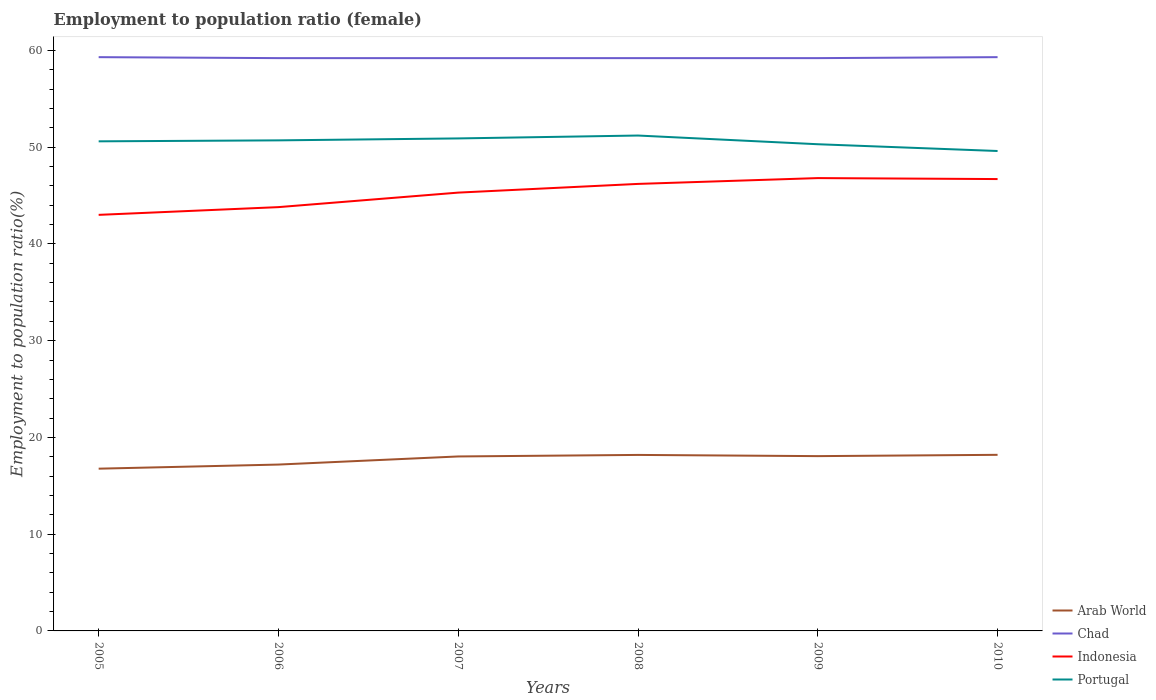Is the number of lines equal to the number of legend labels?
Ensure brevity in your answer.  Yes. Across all years, what is the maximum employment to population ratio in Portugal?
Your response must be concise. 49.6. In which year was the employment to population ratio in Portugal maximum?
Your response must be concise. 2010. What is the difference between the highest and the second highest employment to population ratio in Arab World?
Make the answer very short. 1.43. Is the employment to population ratio in Portugal strictly greater than the employment to population ratio in Chad over the years?
Your answer should be very brief. Yes. How many lines are there?
Your answer should be very brief. 4. What is the difference between two consecutive major ticks on the Y-axis?
Offer a terse response. 10. How are the legend labels stacked?
Offer a very short reply. Vertical. What is the title of the graph?
Your answer should be very brief. Employment to population ratio (female). Does "OECD members" appear as one of the legend labels in the graph?
Your answer should be compact. No. What is the Employment to population ratio(%) in Arab World in 2005?
Give a very brief answer. 16.77. What is the Employment to population ratio(%) in Chad in 2005?
Ensure brevity in your answer.  59.3. What is the Employment to population ratio(%) in Indonesia in 2005?
Make the answer very short. 43. What is the Employment to population ratio(%) in Portugal in 2005?
Ensure brevity in your answer.  50.6. What is the Employment to population ratio(%) in Arab World in 2006?
Keep it short and to the point. 17.19. What is the Employment to population ratio(%) of Chad in 2006?
Offer a very short reply. 59.2. What is the Employment to population ratio(%) in Indonesia in 2006?
Your answer should be compact. 43.8. What is the Employment to population ratio(%) of Portugal in 2006?
Ensure brevity in your answer.  50.7. What is the Employment to population ratio(%) in Arab World in 2007?
Keep it short and to the point. 18.03. What is the Employment to population ratio(%) of Chad in 2007?
Give a very brief answer. 59.2. What is the Employment to population ratio(%) of Indonesia in 2007?
Make the answer very short. 45.3. What is the Employment to population ratio(%) of Portugal in 2007?
Offer a very short reply. 50.9. What is the Employment to population ratio(%) of Arab World in 2008?
Your response must be concise. 18.19. What is the Employment to population ratio(%) of Chad in 2008?
Offer a very short reply. 59.2. What is the Employment to population ratio(%) in Indonesia in 2008?
Your response must be concise. 46.2. What is the Employment to population ratio(%) of Portugal in 2008?
Give a very brief answer. 51.2. What is the Employment to population ratio(%) in Arab World in 2009?
Give a very brief answer. 18.07. What is the Employment to population ratio(%) in Chad in 2009?
Ensure brevity in your answer.  59.2. What is the Employment to population ratio(%) in Indonesia in 2009?
Offer a very short reply. 46.8. What is the Employment to population ratio(%) of Portugal in 2009?
Your response must be concise. 50.3. What is the Employment to population ratio(%) of Arab World in 2010?
Provide a short and direct response. 18.2. What is the Employment to population ratio(%) in Chad in 2010?
Give a very brief answer. 59.3. What is the Employment to population ratio(%) in Indonesia in 2010?
Ensure brevity in your answer.  46.7. What is the Employment to population ratio(%) in Portugal in 2010?
Make the answer very short. 49.6. Across all years, what is the maximum Employment to population ratio(%) of Arab World?
Ensure brevity in your answer.  18.2. Across all years, what is the maximum Employment to population ratio(%) in Chad?
Keep it short and to the point. 59.3. Across all years, what is the maximum Employment to population ratio(%) of Indonesia?
Offer a terse response. 46.8. Across all years, what is the maximum Employment to population ratio(%) in Portugal?
Make the answer very short. 51.2. Across all years, what is the minimum Employment to population ratio(%) in Arab World?
Offer a very short reply. 16.77. Across all years, what is the minimum Employment to population ratio(%) of Chad?
Give a very brief answer. 59.2. Across all years, what is the minimum Employment to population ratio(%) of Indonesia?
Keep it short and to the point. 43. Across all years, what is the minimum Employment to population ratio(%) in Portugal?
Your response must be concise. 49.6. What is the total Employment to population ratio(%) of Arab World in the graph?
Keep it short and to the point. 106.45. What is the total Employment to population ratio(%) of Chad in the graph?
Offer a very short reply. 355.4. What is the total Employment to population ratio(%) in Indonesia in the graph?
Offer a very short reply. 271.8. What is the total Employment to population ratio(%) in Portugal in the graph?
Offer a terse response. 303.3. What is the difference between the Employment to population ratio(%) of Arab World in 2005 and that in 2006?
Make the answer very short. -0.43. What is the difference between the Employment to population ratio(%) of Chad in 2005 and that in 2006?
Give a very brief answer. 0.1. What is the difference between the Employment to population ratio(%) of Indonesia in 2005 and that in 2006?
Offer a very short reply. -0.8. What is the difference between the Employment to population ratio(%) in Portugal in 2005 and that in 2006?
Your answer should be compact. -0.1. What is the difference between the Employment to population ratio(%) of Arab World in 2005 and that in 2007?
Make the answer very short. -1.26. What is the difference between the Employment to population ratio(%) in Chad in 2005 and that in 2007?
Keep it short and to the point. 0.1. What is the difference between the Employment to population ratio(%) in Indonesia in 2005 and that in 2007?
Your answer should be very brief. -2.3. What is the difference between the Employment to population ratio(%) in Portugal in 2005 and that in 2007?
Provide a succinct answer. -0.3. What is the difference between the Employment to population ratio(%) of Arab World in 2005 and that in 2008?
Your response must be concise. -1.42. What is the difference between the Employment to population ratio(%) of Portugal in 2005 and that in 2008?
Make the answer very short. -0.6. What is the difference between the Employment to population ratio(%) in Arab World in 2005 and that in 2009?
Ensure brevity in your answer.  -1.3. What is the difference between the Employment to population ratio(%) of Chad in 2005 and that in 2009?
Your answer should be very brief. 0.1. What is the difference between the Employment to population ratio(%) in Indonesia in 2005 and that in 2009?
Keep it short and to the point. -3.8. What is the difference between the Employment to population ratio(%) in Arab World in 2005 and that in 2010?
Your answer should be compact. -1.43. What is the difference between the Employment to population ratio(%) of Portugal in 2005 and that in 2010?
Give a very brief answer. 1. What is the difference between the Employment to population ratio(%) of Arab World in 2006 and that in 2007?
Provide a short and direct response. -0.84. What is the difference between the Employment to population ratio(%) in Arab World in 2006 and that in 2008?
Your answer should be very brief. -1. What is the difference between the Employment to population ratio(%) in Chad in 2006 and that in 2008?
Offer a very short reply. 0. What is the difference between the Employment to population ratio(%) of Indonesia in 2006 and that in 2008?
Provide a short and direct response. -2.4. What is the difference between the Employment to population ratio(%) in Arab World in 2006 and that in 2009?
Keep it short and to the point. -0.87. What is the difference between the Employment to population ratio(%) in Chad in 2006 and that in 2009?
Your answer should be compact. 0. What is the difference between the Employment to population ratio(%) of Portugal in 2006 and that in 2009?
Offer a terse response. 0.4. What is the difference between the Employment to population ratio(%) in Arab World in 2006 and that in 2010?
Give a very brief answer. -1. What is the difference between the Employment to population ratio(%) in Portugal in 2006 and that in 2010?
Provide a succinct answer. 1.1. What is the difference between the Employment to population ratio(%) in Arab World in 2007 and that in 2008?
Offer a terse response. -0.16. What is the difference between the Employment to population ratio(%) in Indonesia in 2007 and that in 2008?
Give a very brief answer. -0.9. What is the difference between the Employment to population ratio(%) in Portugal in 2007 and that in 2008?
Your response must be concise. -0.3. What is the difference between the Employment to population ratio(%) of Arab World in 2007 and that in 2009?
Give a very brief answer. -0.03. What is the difference between the Employment to population ratio(%) in Chad in 2007 and that in 2009?
Offer a terse response. 0. What is the difference between the Employment to population ratio(%) in Arab World in 2007 and that in 2010?
Provide a succinct answer. -0.17. What is the difference between the Employment to population ratio(%) in Portugal in 2007 and that in 2010?
Give a very brief answer. 1.3. What is the difference between the Employment to population ratio(%) in Arab World in 2008 and that in 2009?
Make the answer very short. 0.12. What is the difference between the Employment to population ratio(%) in Chad in 2008 and that in 2009?
Offer a terse response. 0. What is the difference between the Employment to population ratio(%) of Portugal in 2008 and that in 2009?
Make the answer very short. 0.9. What is the difference between the Employment to population ratio(%) of Arab World in 2008 and that in 2010?
Ensure brevity in your answer.  -0.01. What is the difference between the Employment to population ratio(%) in Chad in 2008 and that in 2010?
Keep it short and to the point. -0.1. What is the difference between the Employment to population ratio(%) in Indonesia in 2008 and that in 2010?
Provide a short and direct response. -0.5. What is the difference between the Employment to population ratio(%) in Portugal in 2008 and that in 2010?
Ensure brevity in your answer.  1.6. What is the difference between the Employment to population ratio(%) in Arab World in 2009 and that in 2010?
Offer a terse response. -0.13. What is the difference between the Employment to population ratio(%) of Portugal in 2009 and that in 2010?
Your answer should be compact. 0.7. What is the difference between the Employment to population ratio(%) of Arab World in 2005 and the Employment to population ratio(%) of Chad in 2006?
Your response must be concise. -42.43. What is the difference between the Employment to population ratio(%) in Arab World in 2005 and the Employment to population ratio(%) in Indonesia in 2006?
Give a very brief answer. -27.03. What is the difference between the Employment to population ratio(%) in Arab World in 2005 and the Employment to population ratio(%) in Portugal in 2006?
Provide a short and direct response. -33.93. What is the difference between the Employment to population ratio(%) of Arab World in 2005 and the Employment to population ratio(%) of Chad in 2007?
Provide a short and direct response. -42.43. What is the difference between the Employment to population ratio(%) in Arab World in 2005 and the Employment to population ratio(%) in Indonesia in 2007?
Your answer should be compact. -28.53. What is the difference between the Employment to population ratio(%) in Arab World in 2005 and the Employment to population ratio(%) in Portugal in 2007?
Keep it short and to the point. -34.13. What is the difference between the Employment to population ratio(%) in Chad in 2005 and the Employment to population ratio(%) in Portugal in 2007?
Offer a terse response. 8.4. What is the difference between the Employment to population ratio(%) of Arab World in 2005 and the Employment to population ratio(%) of Chad in 2008?
Keep it short and to the point. -42.43. What is the difference between the Employment to population ratio(%) in Arab World in 2005 and the Employment to population ratio(%) in Indonesia in 2008?
Provide a short and direct response. -29.43. What is the difference between the Employment to population ratio(%) in Arab World in 2005 and the Employment to population ratio(%) in Portugal in 2008?
Provide a succinct answer. -34.43. What is the difference between the Employment to population ratio(%) in Chad in 2005 and the Employment to population ratio(%) in Indonesia in 2008?
Your answer should be very brief. 13.1. What is the difference between the Employment to population ratio(%) in Chad in 2005 and the Employment to population ratio(%) in Portugal in 2008?
Ensure brevity in your answer.  8.1. What is the difference between the Employment to population ratio(%) of Arab World in 2005 and the Employment to population ratio(%) of Chad in 2009?
Your response must be concise. -42.43. What is the difference between the Employment to population ratio(%) of Arab World in 2005 and the Employment to population ratio(%) of Indonesia in 2009?
Your answer should be compact. -30.03. What is the difference between the Employment to population ratio(%) of Arab World in 2005 and the Employment to population ratio(%) of Portugal in 2009?
Provide a succinct answer. -33.53. What is the difference between the Employment to population ratio(%) in Arab World in 2005 and the Employment to population ratio(%) in Chad in 2010?
Keep it short and to the point. -42.53. What is the difference between the Employment to population ratio(%) in Arab World in 2005 and the Employment to population ratio(%) in Indonesia in 2010?
Keep it short and to the point. -29.93. What is the difference between the Employment to population ratio(%) in Arab World in 2005 and the Employment to population ratio(%) in Portugal in 2010?
Give a very brief answer. -32.83. What is the difference between the Employment to population ratio(%) in Chad in 2005 and the Employment to population ratio(%) in Indonesia in 2010?
Keep it short and to the point. 12.6. What is the difference between the Employment to population ratio(%) of Chad in 2005 and the Employment to population ratio(%) of Portugal in 2010?
Your response must be concise. 9.7. What is the difference between the Employment to population ratio(%) of Indonesia in 2005 and the Employment to population ratio(%) of Portugal in 2010?
Offer a very short reply. -6.6. What is the difference between the Employment to population ratio(%) in Arab World in 2006 and the Employment to population ratio(%) in Chad in 2007?
Offer a terse response. -42.01. What is the difference between the Employment to population ratio(%) in Arab World in 2006 and the Employment to population ratio(%) in Indonesia in 2007?
Offer a terse response. -28.11. What is the difference between the Employment to population ratio(%) in Arab World in 2006 and the Employment to population ratio(%) in Portugal in 2007?
Make the answer very short. -33.71. What is the difference between the Employment to population ratio(%) in Indonesia in 2006 and the Employment to population ratio(%) in Portugal in 2007?
Offer a terse response. -7.1. What is the difference between the Employment to population ratio(%) of Arab World in 2006 and the Employment to population ratio(%) of Chad in 2008?
Offer a very short reply. -42.01. What is the difference between the Employment to population ratio(%) in Arab World in 2006 and the Employment to population ratio(%) in Indonesia in 2008?
Provide a short and direct response. -29.01. What is the difference between the Employment to population ratio(%) in Arab World in 2006 and the Employment to population ratio(%) in Portugal in 2008?
Your answer should be very brief. -34.01. What is the difference between the Employment to population ratio(%) of Indonesia in 2006 and the Employment to population ratio(%) of Portugal in 2008?
Provide a short and direct response. -7.4. What is the difference between the Employment to population ratio(%) of Arab World in 2006 and the Employment to population ratio(%) of Chad in 2009?
Offer a terse response. -42.01. What is the difference between the Employment to population ratio(%) of Arab World in 2006 and the Employment to population ratio(%) of Indonesia in 2009?
Offer a very short reply. -29.61. What is the difference between the Employment to population ratio(%) of Arab World in 2006 and the Employment to population ratio(%) of Portugal in 2009?
Your answer should be compact. -33.11. What is the difference between the Employment to population ratio(%) in Arab World in 2006 and the Employment to population ratio(%) in Chad in 2010?
Give a very brief answer. -42.11. What is the difference between the Employment to population ratio(%) of Arab World in 2006 and the Employment to population ratio(%) of Indonesia in 2010?
Provide a short and direct response. -29.51. What is the difference between the Employment to population ratio(%) of Arab World in 2006 and the Employment to population ratio(%) of Portugal in 2010?
Keep it short and to the point. -32.41. What is the difference between the Employment to population ratio(%) in Chad in 2006 and the Employment to population ratio(%) in Indonesia in 2010?
Your answer should be compact. 12.5. What is the difference between the Employment to population ratio(%) in Arab World in 2007 and the Employment to population ratio(%) in Chad in 2008?
Your response must be concise. -41.17. What is the difference between the Employment to population ratio(%) in Arab World in 2007 and the Employment to population ratio(%) in Indonesia in 2008?
Offer a terse response. -28.17. What is the difference between the Employment to population ratio(%) in Arab World in 2007 and the Employment to population ratio(%) in Portugal in 2008?
Give a very brief answer. -33.17. What is the difference between the Employment to population ratio(%) of Arab World in 2007 and the Employment to population ratio(%) of Chad in 2009?
Offer a terse response. -41.17. What is the difference between the Employment to population ratio(%) in Arab World in 2007 and the Employment to population ratio(%) in Indonesia in 2009?
Give a very brief answer. -28.77. What is the difference between the Employment to population ratio(%) in Arab World in 2007 and the Employment to population ratio(%) in Portugal in 2009?
Provide a succinct answer. -32.27. What is the difference between the Employment to population ratio(%) of Chad in 2007 and the Employment to population ratio(%) of Indonesia in 2009?
Give a very brief answer. 12.4. What is the difference between the Employment to population ratio(%) in Chad in 2007 and the Employment to population ratio(%) in Portugal in 2009?
Offer a very short reply. 8.9. What is the difference between the Employment to population ratio(%) in Arab World in 2007 and the Employment to population ratio(%) in Chad in 2010?
Offer a terse response. -41.27. What is the difference between the Employment to population ratio(%) in Arab World in 2007 and the Employment to population ratio(%) in Indonesia in 2010?
Provide a short and direct response. -28.67. What is the difference between the Employment to population ratio(%) of Arab World in 2007 and the Employment to population ratio(%) of Portugal in 2010?
Provide a short and direct response. -31.57. What is the difference between the Employment to population ratio(%) of Indonesia in 2007 and the Employment to population ratio(%) of Portugal in 2010?
Offer a very short reply. -4.3. What is the difference between the Employment to population ratio(%) of Arab World in 2008 and the Employment to population ratio(%) of Chad in 2009?
Give a very brief answer. -41.01. What is the difference between the Employment to population ratio(%) in Arab World in 2008 and the Employment to population ratio(%) in Indonesia in 2009?
Provide a succinct answer. -28.61. What is the difference between the Employment to population ratio(%) of Arab World in 2008 and the Employment to population ratio(%) of Portugal in 2009?
Ensure brevity in your answer.  -32.11. What is the difference between the Employment to population ratio(%) of Chad in 2008 and the Employment to population ratio(%) of Portugal in 2009?
Make the answer very short. 8.9. What is the difference between the Employment to population ratio(%) in Arab World in 2008 and the Employment to population ratio(%) in Chad in 2010?
Give a very brief answer. -41.11. What is the difference between the Employment to population ratio(%) of Arab World in 2008 and the Employment to population ratio(%) of Indonesia in 2010?
Offer a terse response. -28.51. What is the difference between the Employment to population ratio(%) in Arab World in 2008 and the Employment to population ratio(%) in Portugal in 2010?
Make the answer very short. -31.41. What is the difference between the Employment to population ratio(%) of Chad in 2008 and the Employment to population ratio(%) of Indonesia in 2010?
Give a very brief answer. 12.5. What is the difference between the Employment to population ratio(%) in Arab World in 2009 and the Employment to population ratio(%) in Chad in 2010?
Give a very brief answer. -41.23. What is the difference between the Employment to population ratio(%) in Arab World in 2009 and the Employment to population ratio(%) in Indonesia in 2010?
Keep it short and to the point. -28.63. What is the difference between the Employment to population ratio(%) in Arab World in 2009 and the Employment to population ratio(%) in Portugal in 2010?
Ensure brevity in your answer.  -31.53. What is the difference between the Employment to population ratio(%) in Chad in 2009 and the Employment to population ratio(%) in Indonesia in 2010?
Ensure brevity in your answer.  12.5. What is the difference between the Employment to population ratio(%) in Chad in 2009 and the Employment to population ratio(%) in Portugal in 2010?
Your response must be concise. 9.6. What is the difference between the Employment to population ratio(%) of Indonesia in 2009 and the Employment to population ratio(%) of Portugal in 2010?
Provide a succinct answer. -2.8. What is the average Employment to population ratio(%) of Arab World per year?
Your answer should be very brief. 17.74. What is the average Employment to population ratio(%) in Chad per year?
Your response must be concise. 59.23. What is the average Employment to population ratio(%) of Indonesia per year?
Offer a terse response. 45.3. What is the average Employment to population ratio(%) of Portugal per year?
Give a very brief answer. 50.55. In the year 2005, what is the difference between the Employment to population ratio(%) in Arab World and Employment to population ratio(%) in Chad?
Offer a terse response. -42.53. In the year 2005, what is the difference between the Employment to population ratio(%) of Arab World and Employment to population ratio(%) of Indonesia?
Provide a succinct answer. -26.23. In the year 2005, what is the difference between the Employment to population ratio(%) of Arab World and Employment to population ratio(%) of Portugal?
Make the answer very short. -33.83. In the year 2005, what is the difference between the Employment to population ratio(%) in Indonesia and Employment to population ratio(%) in Portugal?
Offer a very short reply. -7.6. In the year 2006, what is the difference between the Employment to population ratio(%) of Arab World and Employment to population ratio(%) of Chad?
Ensure brevity in your answer.  -42.01. In the year 2006, what is the difference between the Employment to population ratio(%) of Arab World and Employment to population ratio(%) of Indonesia?
Your response must be concise. -26.61. In the year 2006, what is the difference between the Employment to population ratio(%) of Arab World and Employment to population ratio(%) of Portugal?
Ensure brevity in your answer.  -33.51. In the year 2006, what is the difference between the Employment to population ratio(%) in Chad and Employment to population ratio(%) in Indonesia?
Keep it short and to the point. 15.4. In the year 2006, what is the difference between the Employment to population ratio(%) of Indonesia and Employment to population ratio(%) of Portugal?
Offer a terse response. -6.9. In the year 2007, what is the difference between the Employment to population ratio(%) of Arab World and Employment to population ratio(%) of Chad?
Offer a very short reply. -41.17. In the year 2007, what is the difference between the Employment to population ratio(%) of Arab World and Employment to population ratio(%) of Indonesia?
Your response must be concise. -27.27. In the year 2007, what is the difference between the Employment to population ratio(%) of Arab World and Employment to population ratio(%) of Portugal?
Provide a succinct answer. -32.87. In the year 2007, what is the difference between the Employment to population ratio(%) of Chad and Employment to population ratio(%) of Indonesia?
Provide a short and direct response. 13.9. In the year 2008, what is the difference between the Employment to population ratio(%) in Arab World and Employment to population ratio(%) in Chad?
Keep it short and to the point. -41.01. In the year 2008, what is the difference between the Employment to population ratio(%) of Arab World and Employment to population ratio(%) of Indonesia?
Your answer should be very brief. -28.01. In the year 2008, what is the difference between the Employment to population ratio(%) in Arab World and Employment to population ratio(%) in Portugal?
Offer a very short reply. -33.01. In the year 2009, what is the difference between the Employment to population ratio(%) of Arab World and Employment to population ratio(%) of Chad?
Your answer should be compact. -41.13. In the year 2009, what is the difference between the Employment to population ratio(%) in Arab World and Employment to population ratio(%) in Indonesia?
Offer a terse response. -28.73. In the year 2009, what is the difference between the Employment to population ratio(%) in Arab World and Employment to population ratio(%) in Portugal?
Offer a very short reply. -32.23. In the year 2009, what is the difference between the Employment to population ratio(%) of Chad and Employment to population ratio(%) of Indonesia?
Keep it short and to the point. 12.4. In the year 2009, what is the difference between the Employment to population ratio(%) of Indonesia and Employment to population ratio(%) of Portugal?
Your answer should be compact. -3.5. In the year 2010, what is the difference between the Employment to population ratio(%) in Arab World and Employment to population ratio(%) in Chad?
Provide a short and direct response. -41.1. In the year 2010, what is the difference between the Employment to population ratio(%) in Arab World and Employment to population ratio(%) in Indonesia?
Your response must be concise. -28.5. In the year 2010, what is the difference between the Employment to population ratio(%) in Arab World and Employment to population ratio(%) in Portugal?
Your answer should be compact. -31.4. In the year 2010, what is the difference between the Employment to population ratio(%) in Chad and Employment to population ratio(%) in Indonesia?
Offer a terse response. 12.6. In the year 2010, what is the difference between the Employment to population ratio(%) in Indonesia and Employment to population ratio(%) in Portugal?
Keep it short and to the point. -2.9. What is the ratio of the Employment to population ratio(%) in Arab World in 2005 to that in 2006?
Offer a terse response. 0.98. What is the ratio of the Employment to population ratio(%) of Indonesia in 2005 to that in 2006?
Keep it short and to the point. 0.98. What is the ratio of the Employment to population ratio(%) in Portugal in 2005 to that in 2006?
Ensure brevity in your answer.  1. What is the ratio of the Employment to population ratio(%) of Arab World in 2005 to that in 2007?
Your answer should be compact. 0.93. What is the ratio of the Employment to population ratio(%) in Indonesia in 2005 to that in 2007?
Make the answer very short. 0.95. What is the ratio of the Employment to population ratio(%) in Arab World in 2005 to that in 2008?
Keep it short and to the point. 0.92. What is the ratio of the Employment to population ratio(%) of Indonesia in 2005 to that in 2008?
Your answer should be compact. 0.93. What is the ratio of the Employment to population ratio(%) of Portugal in 2005 to that in 2008?
Provide a succinct answer. 0.99. What is the ratio of the Employment to population ratio(%) in Arab World in 2005 to that in 2009?
Provide a short and direct response. 0.93. What is the ratio of the Employment to population ratio(%) of Indonesia in 2005 to that in 2009?
Give a very brief answer. 0.92. What is the ratio of the Employment to population ratio(%) in Portugal in 2005 to that in 2009?
Provide a short and direct response. 1.01. What is the ratio of the Employment to population ratio(%) in Arab World in 2005 to that in 2010?
Make the answer very short. 0.92. What is the ratio of the Employment to population ratio(%) of Chad in 2005 to that in 2010?
Your answer should be very brief. 1. What is the ratio of the Employment to population ratio(%) of Indonesia in 2005 to that in 2010?
Offer a terse response. 0.92. What is the ratio of the Employment to population ratio(%) in Portugal in 2005 to that in 2010?
Provide a succinct answer. 1.02. What is the ratio of the Employment to population ratio(%) of Arab World in 2006 to that in 2007?
Offer a very short reply. 0.95. What is the ratio of the Employment to population ratio(%) of Chad in 2006 to that in 2007?
Make the answer very short. 1. What is the ratio of the Employment to population ratio(%) in Indonesia in 2006 to that in 2007?
Keep it short and to the point. 0.97. What is the ratio of the Employment to population ratio(%) in Portugal in 2006 to that in 2007?
Keep it short and to the point. 1. What is the ratio of the Employment to population ratio(%) of Arab World in 2006 to that in 2008?
Give a very brief answer. 0.95. What is the ratio of the Employment to population ratio(%) of Chad in 2006 to that in 2008?
Your answer should be very brief. 1. What is the ratio of the Employment to population ratio(%) in Indonesia in 2006 to that in 2008?
Provide a short and direct response. 0.95. What is the ratio of the Employment to population ratio(%) in Portugal in 2006 to that in 2008?
Your response must be concise. 0.99. What is the ratio of the Employment to population ratio(%) of Arab World in 2006 to that in 2009?
Offer a very short reply. 0.95. What is the ratio of the Employment to population ratio(%) of Indonesia in 2006 to that in 2009?
Your answer should be compact. 0.94. What is the ratio of the Employment to population ratio(%) in Portugal in 2006 to that in 2009?
Your answer should be compact. 1.01. What is the ratio of the Employment to population ratio(%) of Arab World in 2006 to that in 2010?
Offer a very short reply. 0.94. What is the ratio of the Employment to population ratio(%) of Chad in 2006 to that in 2010?
Offer a very short reply. 1. What is the ratio of the Employment to population ratio(%) in Indonesia in 2006 to that in 2010?
Your response must be concise. 0.94. What is the ratio of the Employment to population ratio(%) of Portugal in 2006 to that in 2010?
Offer a terse response. 1.02. What is the ratio of the Employment to population ratio(%) in Arab World in 2007 to that in 2008?
Give a very brief answer. 0.99. What is the ratio of the Employment to population ratio(%) in Indonesia in 2007 to that in 2008?
Make the answer very short. 0.98. What is the ratio of the Employment to population ratio(%) in Arab World in 2007 to that in 2009?
Give a very brief answer. 1. What is the ratio of the Employment to population ratio(%) of Chad in 2007 to that in 2009?
Give a very brief answer. 1. What is the ratio of the Employment to population ratio(%) in Indonesia in 2007 to that in 2009?
Make the answer very short. 0.97. What is the ratio of the Employment to population ratio(%) of Portugal in 2007 to that in 2009?
Offer a terse response. 1.01. What is the ratio of the Employment to population ratio(%) of Arab World in 2007 to that in 2010?
Give a very brief answer. 0.99. What is the ratio of the Employment to population ratio(%) in Indonesia in 2007 to that in 2010?
Give a very brief answer. 0.97. What is the ratio of the Employment to population ratio(%) of Portugal in 2007 to that in 2010?
Your response must be concise. 1.03. What is the ratio of the Employment to population ratio(%) of Chad in 2008 to that in 2009?
Make the answer very short. 1. What is the ratio of the Employment to population ratio(%) of Indonesia in 2008 to that in 2009?
Your answer should be very brief. 0.99. What is the ratio of the Employment to population ratio(%) of Portugal in 2008 to that in 2009?
Provide a short and direct response. 1.02. What is the ratio of the Employment to population ratio(%) of Arab World in 2008 to that in 2010?
Offer a very short reply. 1. What is the ratio of the Employment to population ratio(%) in Chad in 2008 to that in 2010?
Provide a succinct answer. 1. What is the ratio of the Employment to population ratio(%) of Indonesia in 2008 to that in 2010?
Your answer should be compact. 0.99. What is the ratio of the Employment to population ratio(%) in Portugal in 2008 to that in 2010?
Provide a short and direct response. 1.03. What is the ratio of the Employment to population ratio(%) of Portugal in 2009 to that in 2010?
Offer a terse response. 1.01. What is the difference between the highest and the second highest Employment to population ratio(%) of Arab World?
Give a very brief answer. 0.01. What is the difference between the highest and the second highest Employment to population ratio(%) of Chad?
Ensure brevity in your answer.  0. What is the difference between the highest and the lowest Employment to population ratio(%) in Arab World?
Provide a short and direct response. 1.43. What is the difference between the highest and the lowest Employment to population ratio(%) of Chad?
Your response must be concise. 0.1. What is the difference between the highest and the lowest Employment to population ratio(%) in Portugal?
Make the answer very short. 1.6. 